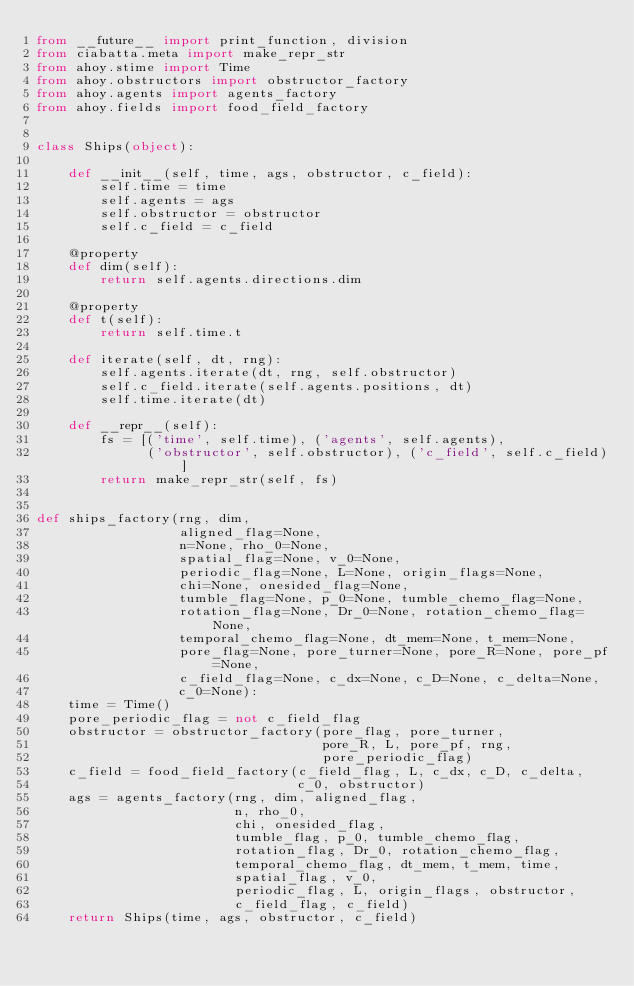Convert code to text. <code><loc_0><loc_0><loc_500><loc_500><_Python_>from __future__ import print_function, division
from ciabatta.meta import make_repr_str
from ahoy.stime import Time
from ahoy.obstructors import obstructor_factory
from ahoy.agents import agents_factory
from ahoy.fields import food_field_factory


class Ships(object):

    def __init__(self, time, ags, obstructor, c_field):
        self.time = time
        self.agents = ags
        self.obstructor = obstructor
        self.c_field = c_field

    @property
    def dim(self):
        return self.agents.directions.dim

    @property
    def t(self):
        return self.time.t

    def iterate(self, dt, rng):
        self.agents.iterate(dt, rng, self.obstructor)
        self.c_field.iterate(self.agents.positions, dt)
        self.time.iterate(dt)

    def __repr__(self):
        fs = [('time', self.time), ('agents', self.agents),
              ('obstructor', self.obstructor), ('c_field', self.c_field)]
        return make_repr_str(self, fs)


def ships_factory(rng, dim,
                  aligned_flag=None,
                  n=None, rho_0=None,
                  spatial_flag=None, v_0=None,
                  periodic_flag=None, L=None, origin_flags=None,
                  chi=None, onesided_flag=None,
                  tumble_flag=None, p_0=None, tumble_chemo_flag=None,
                  rotation_flag=None, Dr_0=None, rotation_chemo_flag=None,
                  temporal_chemo_flag=None, dt_mem=None, t_mem=None,
                  pore_flag=None, pore_turner=None, pore_R=None, pore_pf=None,
                  c_field_flag=None, c_dx=None, c_D=None, c_delta=None,
                  c_0=None):
    time = Time()
    pore_periodic_flag = not c_field_flag
    obstructor = obstructor_factory(pore_flag, pore_turner,
                                    pore_R, L, pore_pf, rng,
                                    pore_periodic_flag)
    c_field = food_field_factory(c_field_flag, L, c_dx, c_D, c_delta,
                                 c_0, obstructor)
    ags = agents_factory(rng, dim, aligned_flag,
                         n, rho_0,
                         chi, onesided_flag,
                         tumble_flag, p_0, tumble_chemo_flag,
                         rotation_flag, Dr_0, rotation_chemo_flag,
                         temporal_chemo_flag, dt_mem, t_mem, time,
                         spatial_flag, v_0,
                         periodic_flag, L, origin_flags, obstructor,
                         c_field_flag, c_field)
    return Ships(time, ags, obstructor, c_field)
</code> 